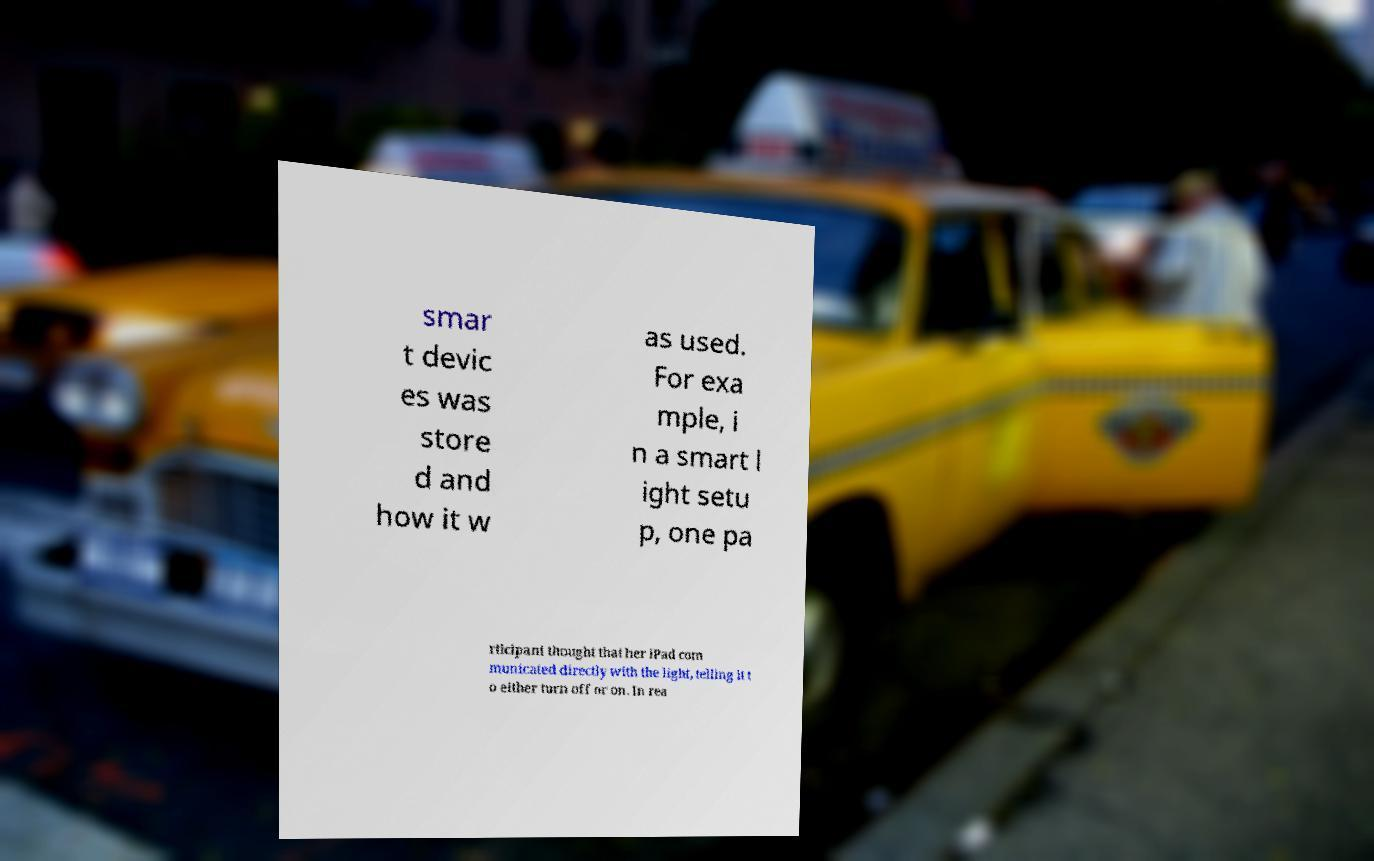Could you extract and type out the text from this image? smar t devic es was store d and how it w as used. For exa mple, i n a smart l ight setu p, one pa rticipant thought that her iPad com municated directly with the light, telling it t o either turn off or on. In rea 